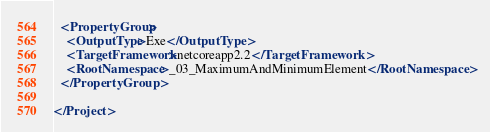<code> <loc_0><loc_0><loc_500><loc_500><_XML_>  <PropertyGroup>
    <OutputType>Exe</OutputType>
    <TargetFramework>netcoreapp2.2</TargetFramework>
    <RootNamespace>_03_MaximumAndMinimumElement</RootNamespace>
  </PropertyGroup>

</Project>
</code> 